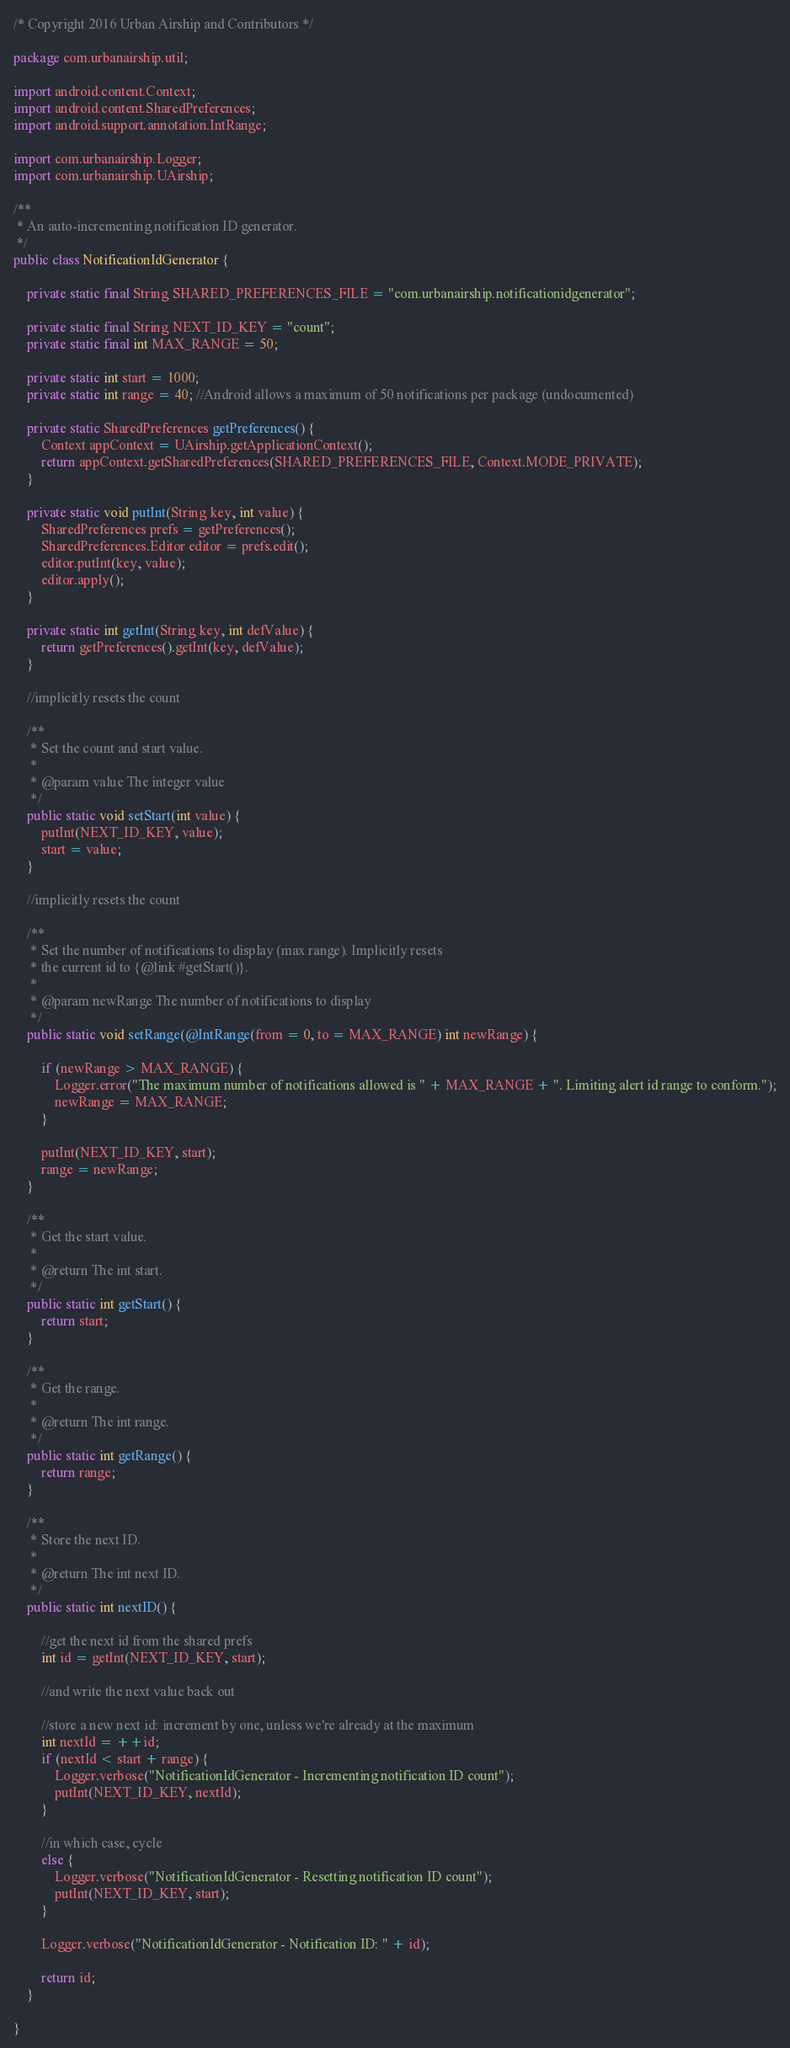Convert code to text. <code><loc_0><loc_0><loc_500><loc_500><_Java_>/* Copyright 2016 Urban Airship and Contributors */

package com.urbanairship.util;

import android.content.Context;
import android.content.SharedPreferences;
import android.support.annotation.IntRange;

import com.urbanairship.Logger;
import com.urbanairship.UAirship;

/**
 * An auto-incrementing notification ID generator.
 */
public class NotificationIdGenerator {

    private static final String SHARED_PREFERENCES_FILE = "com.urbanairship.notificationidgenerator";

    private static final String NEXT_ID_KEY = "count";
    private static final int MAX_RANGE = 50;

    private static int start = 1000;
    private static int range = 40; //Android allows a maximum of 50 notifications per package (undocumented)

    private static SharedPreferences getPreferences() {
        Context appContext = UAirship.getApplicationContext();
        return appContext.getSharedPreferences(SHARED_PREFERENCES_FILE, Context.MODE_PRIVATE);
    }

    private static void putInt(String key, int value) {
        SharedPreferences prefs = getPreferences();
        SharedPreferences.Editor editor = prefs.edit();
        editor.putInt(key, value);
        editor.apply();
    }

    private static int getInt(String key, int defValue) {
        return getPreferences().getInt(key, defValue);
    }

    //implicitly resets the count

    /**
     * Set the count and start value.
     *
     * @param value The integer value
     */
    public static void setStart(int value) {
        putInt(NEXT_ID_KEY, value);
        start = value;
    }

    //implicitly resets the count

    /**
     * Set the number of notifications to display (max range). Implicitly resets
     * the current id to {@link #getStart()}.
     *
     * @param newRange The number of notifications to display
     */
    public static void setRange(@IntRange(from = 0, to = MAX_RANGE) int newRange) {

        if (newRange > MAX_RANGE) {
            Logger.error("The maximum number of notifications allowed is " + MAX_RANGE + ". Limiting alert id range to conform.");
            newRange = MAX_RANGE;
        }

        putInt(NEXT_ID_KEY, start);
        range = newRange;
    }

    /**
     * Get the start value.
     *
     * @return The int start.
     */
    public static int getStart() {
        return start;
    }

    /**
     * Get the range.
     *
     * @return The int range.
     */
    public static int getRange() {
        return range;
    }

    /**
     * Store the next ID.
     *
     * @return The int next ID.
     */
    public static int nextID() {

        //get the next id from the shared prefs
        int id = getInt(NEXT_ID_KEY, start);

        //and write the next value back out

        //store a new next id: increment by one, unless we're already at the maximum
        int nextId = ++id;
        if (nextId < start + range) {
            Logger.verbose("NotificationIdGenerator - Incrementing notification ID count");
            putInt(NEXT_ID_KEY, nextId);
        }

        //in which case, cycle
        else {
            Logger.verbose("NotificationIdGenerator - Resetting notification ID count");
            putInt(NEXT_ID_KEY, start);
        }

        Logger.verbose("NotificationIdGenerator - Notification ID: " + id);

        return id;
    }

}
</code> 